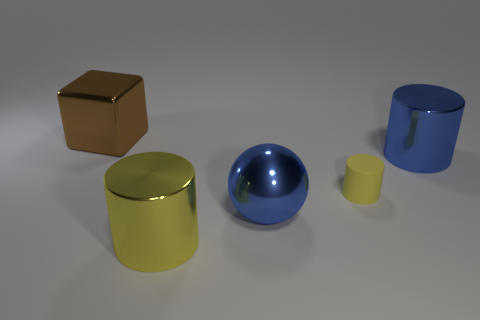There is a cylinder that is behind the matte cylinder; what is its material?
Give a very brief answer. Metal. What number of things are big cylinders that are in front of the small rubber cylinder or tiny brown matte cylinders?
Your answer should be compact. 1. What number of other things are there of the same shape as the matte thing?
Provide a short and direct response. 2. There is a metal thing that is to the left of the yellow shiny thing; does it have the same shape as the tiny yellow matte object?
Keep it short and to the point. No. There is a brown metal thing; are there any brown blocks in front of it?
Your response must be concise. No. How many big things are either yellow metal cubes or yellow cylinders?
Provide a succinct answer. 1. Does the blue sphere have the same material as the large blue cylinder?
Make the answer very short. Yes. There is a cylinder that is the same color as the sphere; what is its size?
Make the answer very short. Large. Are there any shiny objects that have the same color as the cube?
Offer a terse response. No. What is the size of the blue cylinder that is the same material as the large ball?
Your answer should be very brief. Large. 